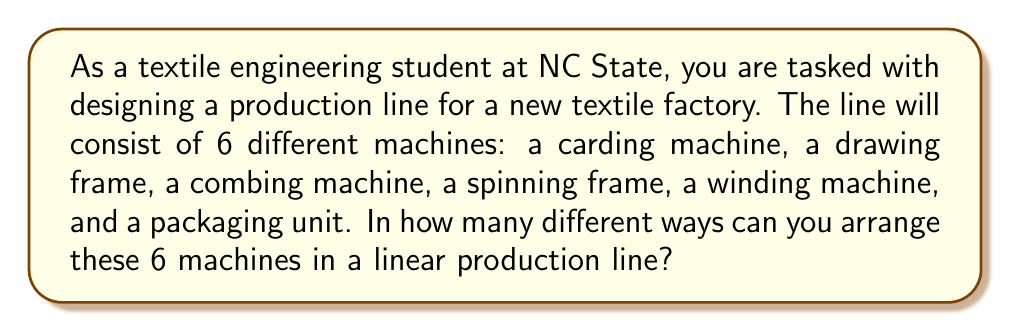Can you solve this math problem? To solve this problem, we need to recognize that this is a permutation problem. We are arranging 6 distinct objects (the different textile machines) in a specific order.

The number of permutations of $n$ distinct objects is given by the formula:

$$P(n) = n!$$

Where $n!$ represents the factorial of $n$.

In this case, we have 6 distinct machines, so $n = 6$.

Therefore, the number of ways to arrange these machines is:

$$P(6) = 6!$$

Let's calculate this:

$$\begin{align}
6! &= 6 \times 5 \times 4 \times 3 \times 2 \times 1 \\
&= 720
\end{align}$$

This means there are 720 different ways to arrange these 6 textile machines in the production line.

To understand why this works, consider that:
1. We have 6 choices for the first machine in the line
2. After placing the first machine, we have 5 choices for the second
3. Then 4 choices for the third, and so on
4. This gives us $6 \times 5 \times 4 \times 3 \times 2 \times 1 = 720$ total arrangements
Answer: There are 720 different ways to arrange the 6 textile machines in the production line. 